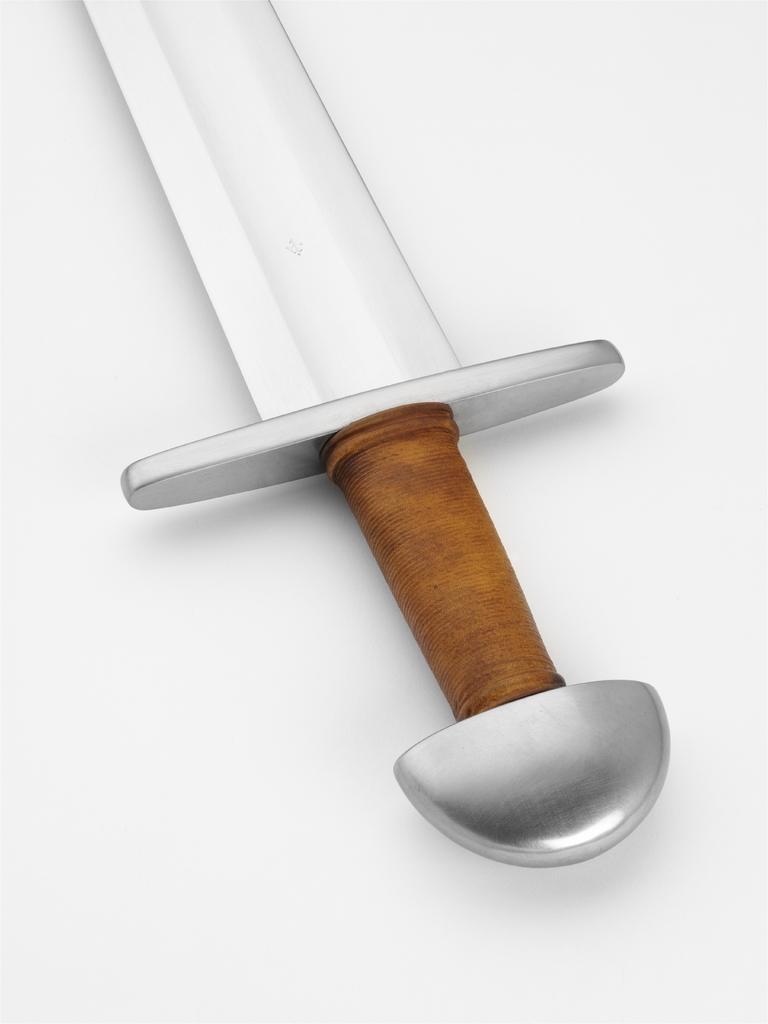Could you give a brief overview of what you see in this image? In this image I can see a sword. The background is in white color. 